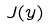<formula> <loc_0><loc_0><loc_500><loc_500>J ( y )</formula> 